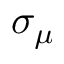Convert formula to latex. <formula><loc_0><loc_0><loc_500><loc_500>\sigma _ { \mu }</formula> 